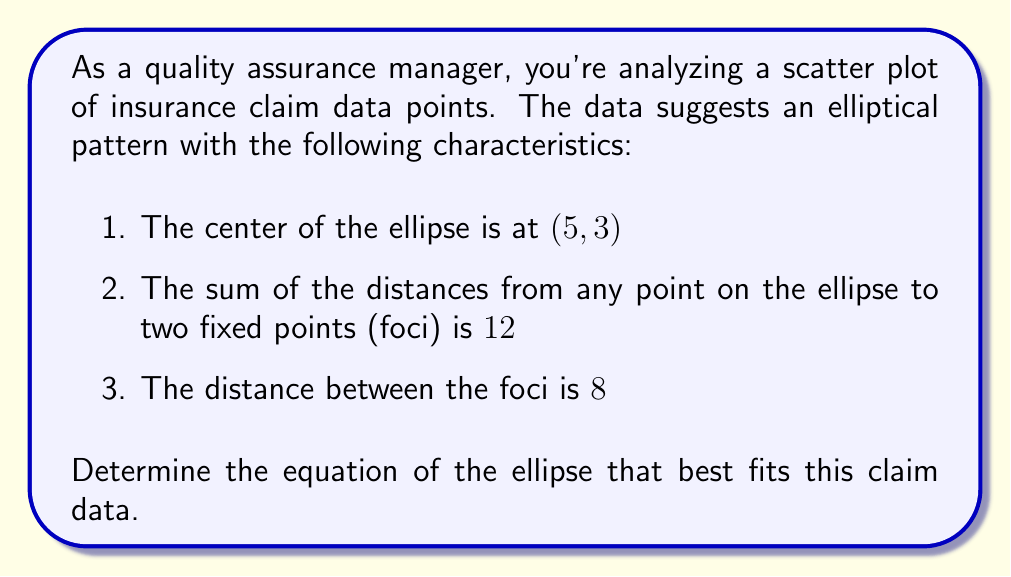Can you answer this question? Let's approach this step-by-step:

1) The general equation of an ellipse with center (h, k) is:

   $$\frac{(x-h)^2}{a^2} + \frac{(y-k)^2}{b^2} = 1$$

   where (h, k) is the center, and a and b are the lengths of the semi-major and semi-minor axes.

2) We're given that the center is at (5, 3), so h = 5 and k = 3.

3) The distance between the foci is 8. In an ellipse, this distance is 2c, where c is the focal distance. So:

   $$2c = 8$$
   $$c = 4$$

4) We're also told that the sum of the distances from any point on the ellipse to the two foci is 12. This sum is always equal to 2a. So:

   $$2a = 12$$
   $$a = 6$$

5) In an ellipse, $a^2 = b^2 + c^2$. We can use this to find b:

   $$6^2 = b^2 + 4^2$$
   $$36 = b^2 + 16$$
   $$b^2 = 20$$
   $$b = 2\sqrt{5}$$

6) Now we have all the components to write the equation. Substituting into the general form:

   $$\frac{(x-5)^2}{6^2} + \frac{(y-3)^2}{(2\sqrt{5})^2} = 1$$

7) Simplifying:

   $$\frac{(x-5)^2}{36} + \frac{(y-3)^2}{20} = 1$$

This is the equation of the ellipse that best fits the claim data points.
Answer: $$\frac{(x-5)^2}{36} + \frac{(y-3)^2}{20} = 1$$ 